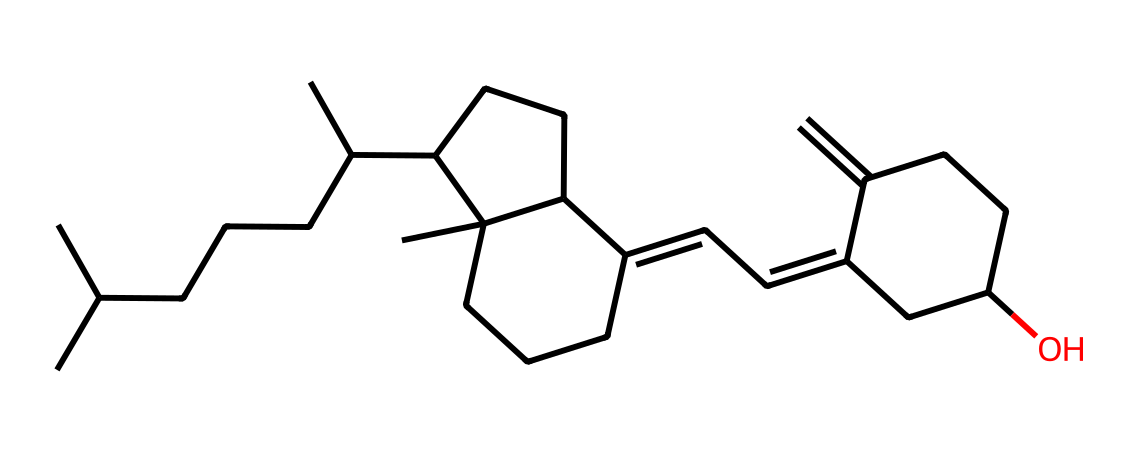What is the main functional group present in this vitamin D structure? The structure contains an alcohol functional group, which is indicated by the presence of a hydroxyl (OH) group in the chemical structure.
Answer: alcohol How many rings are present in this molecular structure? By analyzing the structure, there are four rings identified in the chemical representation. This is counted based on the cyclical nature of the connected carbon atoms.
Answer: four What is the total number of carbon atoms in this vitamin D molecule? Counting the carbon atoms represented in the structure gives a total of 27 carbon atoms present in this molecule.
Answer: 27 Does this molecule have any double bonds? The presence of double bonds can be inferred from the structure where carbon atoms are not fully saturated, indicating that there are indeed double bonds present.
Answer: yes What type of vitamin is represented by this molecular structure? This molecule is classified as fat-soluble vitamin D, which is determined by its non-polar carbon-rich structure that requires lipids for absorption.
Answer: vitamin D Which part of this molecule is involved in the absorption of calcium? The hydroxyl group (-OH) in the structure enhances its ability to interact with biological systems, particularly facilitating calcium absorption in the intestines.
Answer: hydroxyl group 